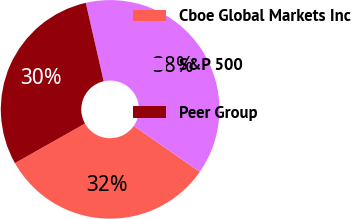Convert chart. <chart><loc_0><loc_0><loc_500><loc_500><pie_chart><fcel>Cboe Global Markets Inc<fcel>S&P 500<fcel>Peer Group<nl><fcel>32.14%<fcel>38.26%<fcel>29.6%<nl></chart> 